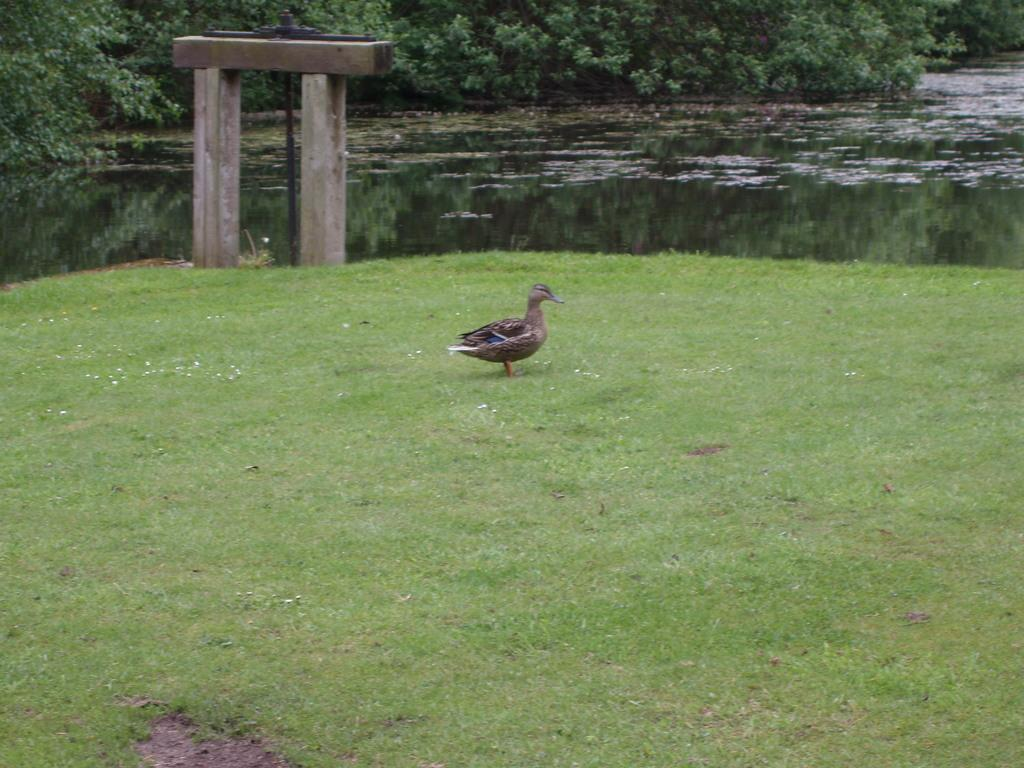What type of animal can be seen in the image? There is a bird in the image. What type of terrain is visible in the image? There is grass in the image. What type of man-made structure is present in the image? There is cement construction in the image. What natural element is visible in the image? There is water visible in the image. What type of vegetation is present in the image? There are plants in the image. What type of leather material is being used to construct the mountain in the image? There is no mountain or leather material present in the image. What type of zinc-based alloy is visible in the image? There is no zinc-based alloy present in the image. 